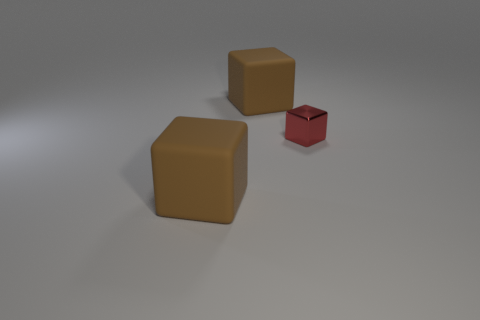Add 2 big brown matte cubes. How many objects exist? 5 Subtract all brown cubes. How many cubes are left? 1 Subtract all purple cylinders. How many brown cubes are left? 2 Subtract 3 blocks. How many blocks are left? 0 Subtract all red cubes. How many cubes are left? 2 Subtract 0 brown balls. How many objects are left? 3 Subtract all gray cubes. Subtract all red cylinders. How many cubes are left? 3 Subtract all big purple matte spheres. Subtract all red cubes. How many objects are left? 2 Add 1 red objects. How many red objects are left? 2 Add 3 brown things. How many brown things exist? 5 